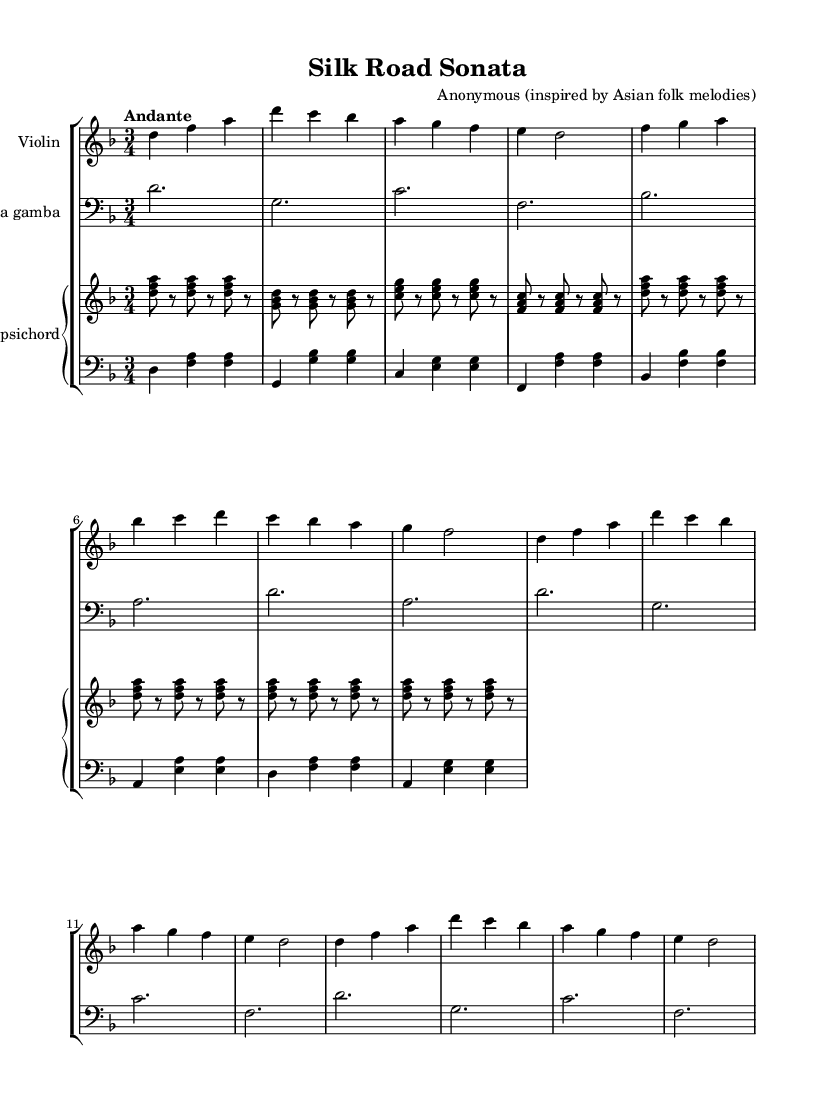What is the key signature of this music? The key signature is D minor, which has one flat (B flat) indicated in the key signature at the beginning of the staff.
Answer: D minor What is the time signature of this music? The time signature is indicated as 3/4, meaning there are three beats in each measure and a quarter note gets one beat.
Answer: 3/4 What tempo marking is indicated for this piece? The tempo marking is "Andante," which is a tempo that is generally slow and walking pace, often used in Baroque music.
Answer: Andante How many measures are repeated in the violin part? The violin part includes two measures that are repeated twice as indicated by the "repeat unfold 2" marking. This means the same sequence is played twice.
Answer: 2 What is the instrumentation used in this piece? The piece is scored for violin, viola da gamba, and a harpsichord (with two staves for the right and left hands), showcasing a typical Baroque chamber ensemble.
Answer: Violin, Viola da gamba, Harpsichord What distinctive elements of Asian folk melodies can be identified in this Baroque composition? The use of melodic intervals and scalar passages that reflect Eastern musical traditions can be noted, reflecting the fusion of styles. However, analyzing the specific folk elements requires knowledge of the particular Asian melodies that inspired the piece.
Answer: Melodic intervals and scales How does the harpsichord contribute to the overall texture of the piece? The harpsichord functions as both a rhythmic and harmonic foundation, with the right hand playing chords and the left hand supporting with bass notes, typical of Baroque texture.
Answer: Rhythmic and harmonic foundation 